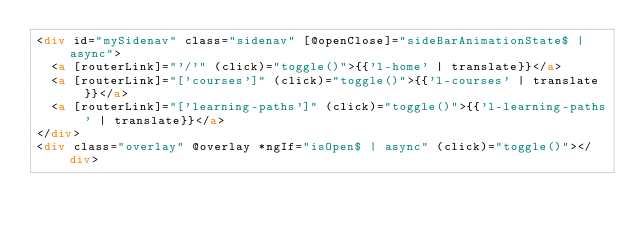<code> <loc_0><loc_0><loc_500><loc_500><_HTML_><div id="mySidenav" class="sidenav" [@openClose]="sideBarAnimationState$ | async">
  <a [routerLink]="'/'" (click)="toggle()">{{'l-home' | translate}}</a>
  <a [routerLink]="['courses']" (click)="toggle()">{{'l-courses' | translate}}</a>
  <a [routerLink]="['learning-paths']" (click)="toggle()">{{'l-learning-paths' | translate}}</a>
</div>
<div class="overlay" @overlay *ngIf="isOpen$ | async" (click)="toggle()"></div>
</code> 